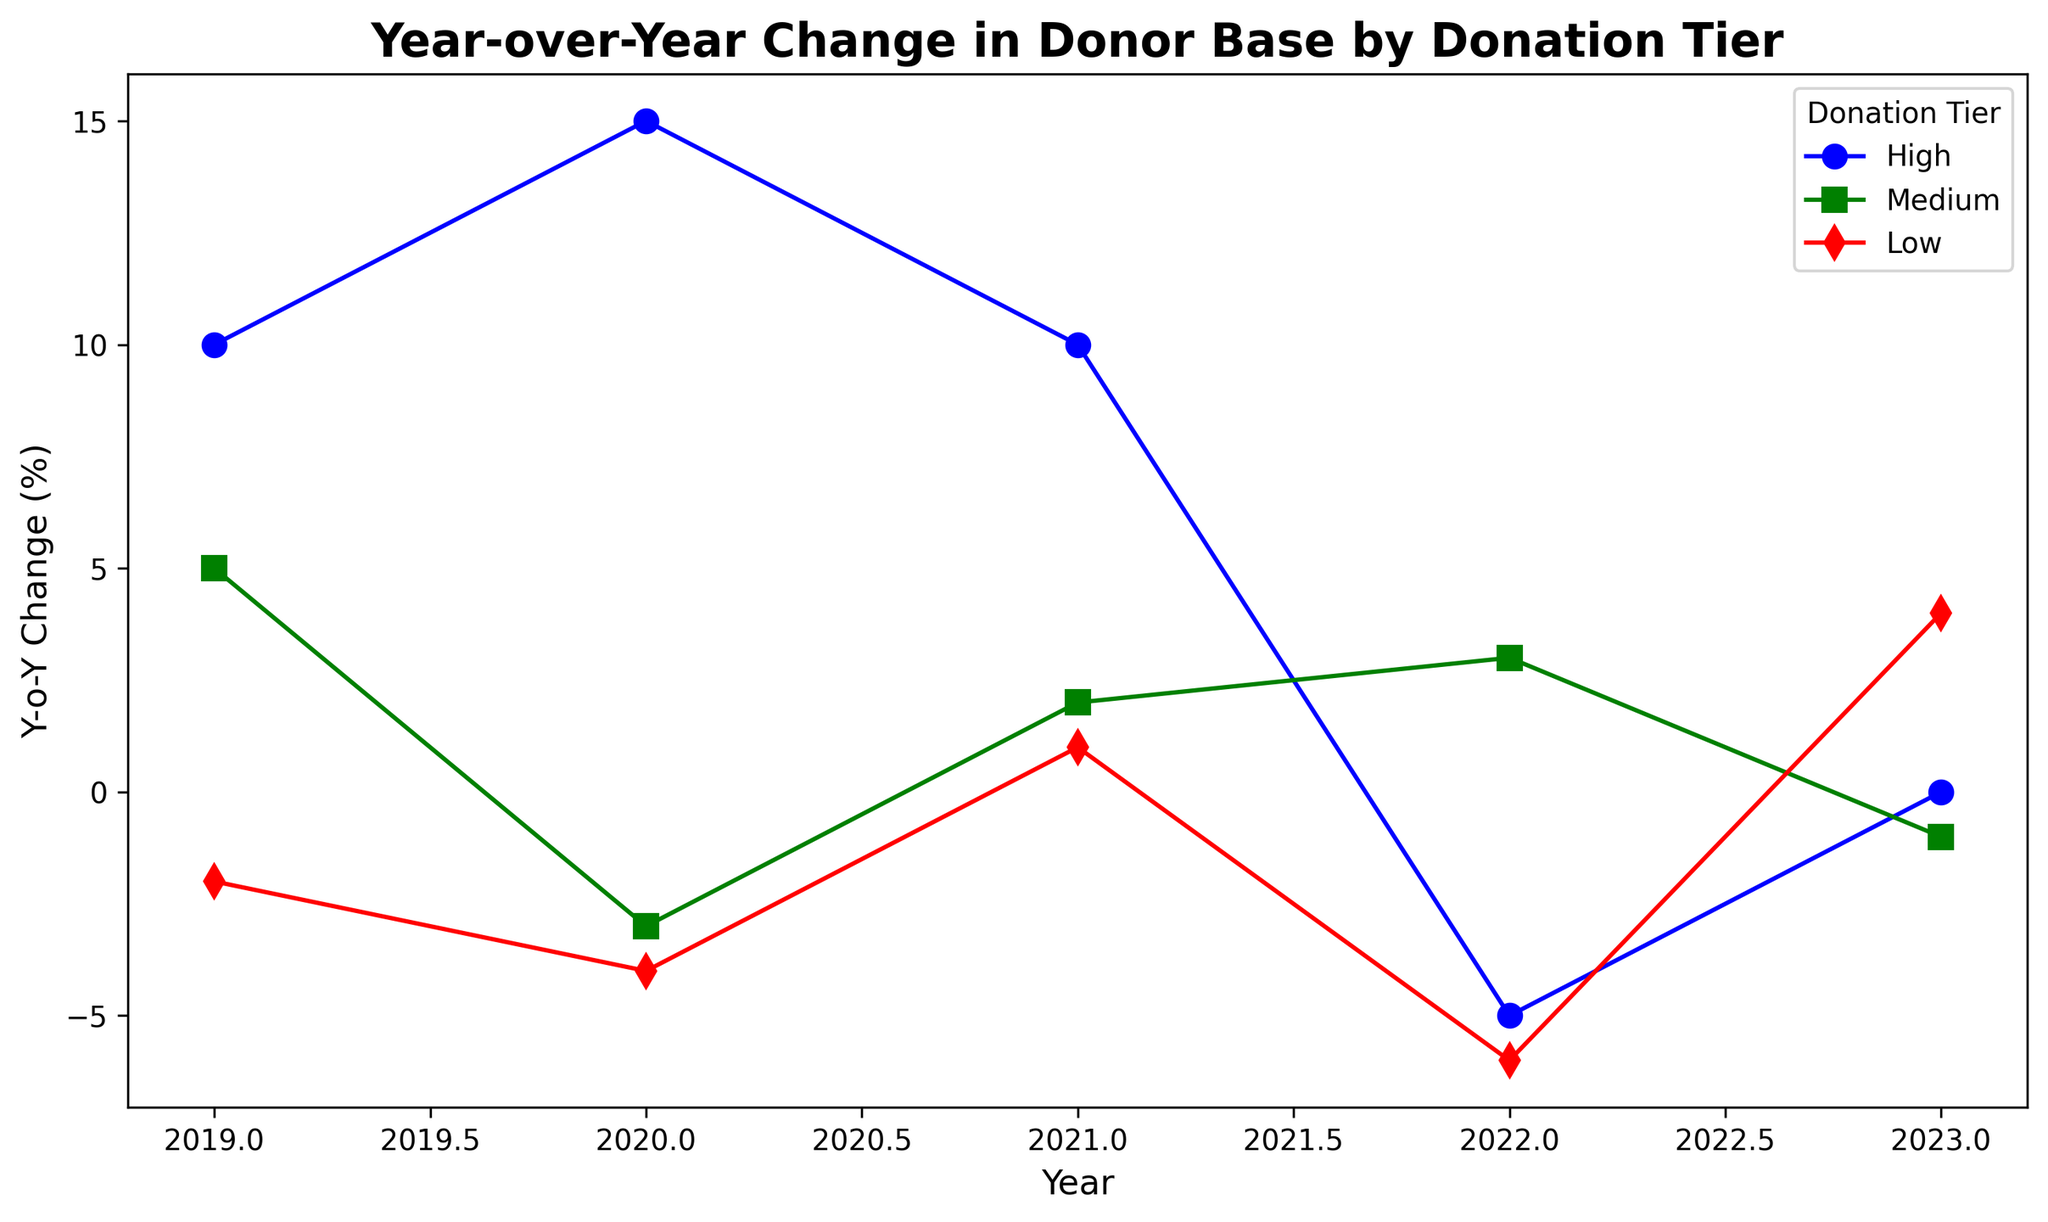What year had the highest year-over-year change for the High donation tier? The highest value for the High donation tier is 15, which occurs in 2020.
Answer: 2020 Compare the year-over-year change for the Medium donation tier in 2019 and 2020. In 2019, the Medium tier has a value of 5, and in 2020, it has a value of -3.
Answer: 5 (2019) vs. -3 (2020) What is the overall trend for the Low donation tier from 2019 to 2023? The values for the Low donation tier from 2019 to 2023 are -2, -4, 1, -6, and 4. Initially, the trend is decreasing until 2020, slightly increasing in 2021, sharply declining in 2022, and then increasing again in 2023.
Answer: Fluctuating trend with an initial decline, slight rise, sharp decline, and rise again Which donation tier experienced the most significant decline in a single year, and what was the value? The High donation tier experienced the most significant decline of -20 from 2021 to 2022 (from 15 to -5).
Answer: High, -20 What year saw the Medium donation tier experiencing negative values for the first time? The Medium donation tier first experienced negative values in 2020 with -3.
Answer: 2020 How many years did the Low donation tier show a negative year-over-year change? The Low donation tier showed negative changes in 2019, 2020, and 2022, totaling 3 years.
Answer: 3 years Compare the year-over-year change for the High donation tier in the years 2019, and 2022. For the High tier, the Y-o-Y change in 2019 is 10, while in 2022, it is -5.
Answer: 10 (2019) vs. -5 (2022) What is the average year-over-year change for the Medium donation tier over the five years? The values for the Medium donation tier over the five years are 5, -3, 2, 3, -1. Adding these values gives 6; dividing by 5 gives an average of 1.2.
Answer: 1.2 How did the year-over-year change in the High tier compare to the Low tier in 2021? In 2021, the High donation tier saw a growth of 10, while the Low donation tier grew by 1.
Answer: 10 (High) vs. 1 (Low) Which donation tier showed a mix of positive and negative values throughout the years? The Medium tier showed both positive (5 in 2019, 2 in 2021, 3 in 2022) and negative (-3 in 2020, -1 in 2023) values.
Answer: Medium 